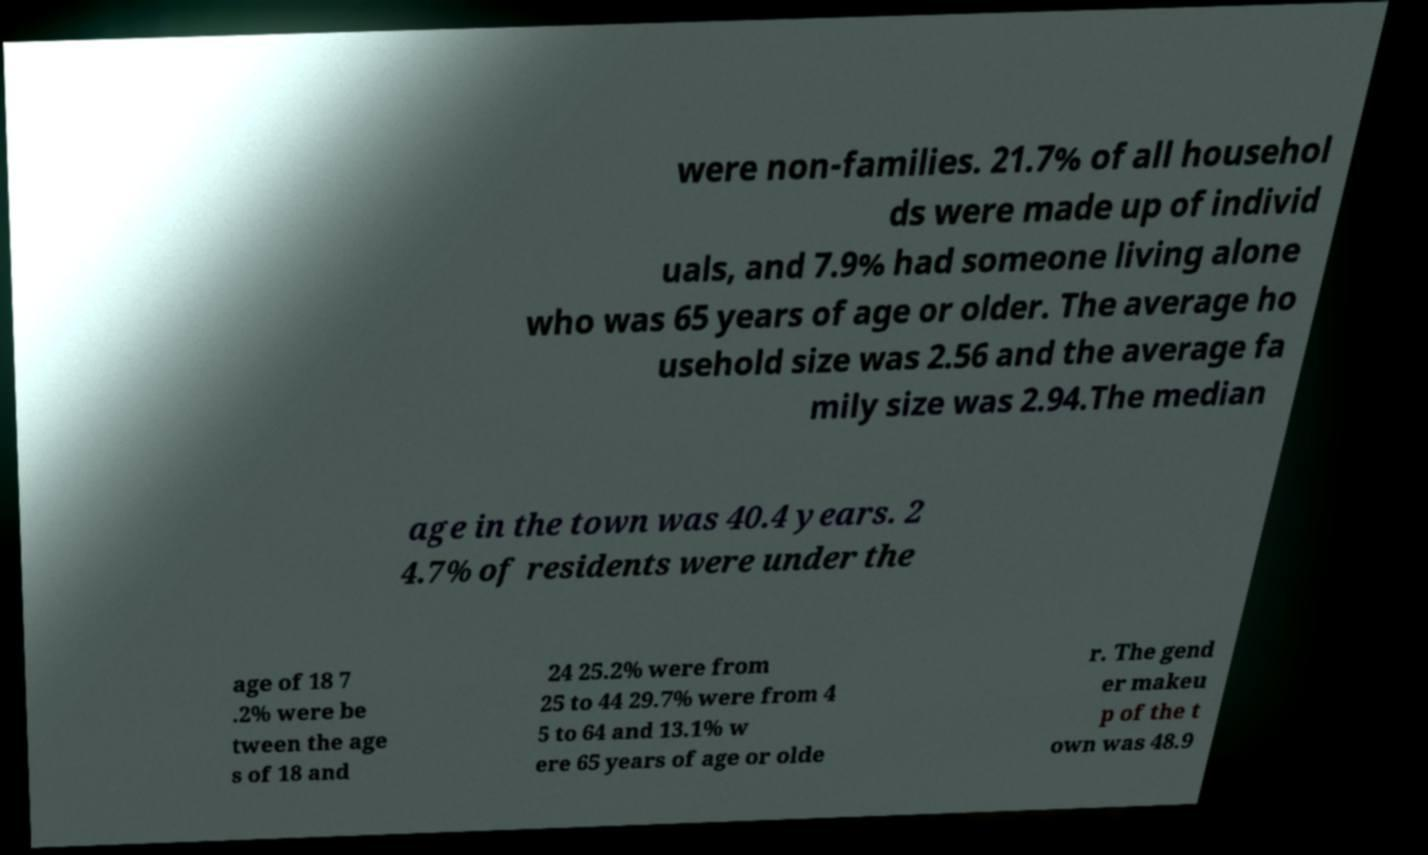I need the written content from this picture converted into text. Can you do that? were non-families. 21.7% of all househol ds were made up of individ uals, and 7.9% had someone living alone who was 65 years of age or older. The average ho usehold size was 2.56 and the average fa mily size was 2.94.The median age in the town was 40.4 years. 2 4.7% of residents were under the age of 18 7 .2% were be tween the age s of 18 and 24 25.2% were from 25 to 44 29.7% were from 4 5 to 64 and 13.1% w ere 65 years of age or olde r. The gend er makeu p of the t own was 48.9 